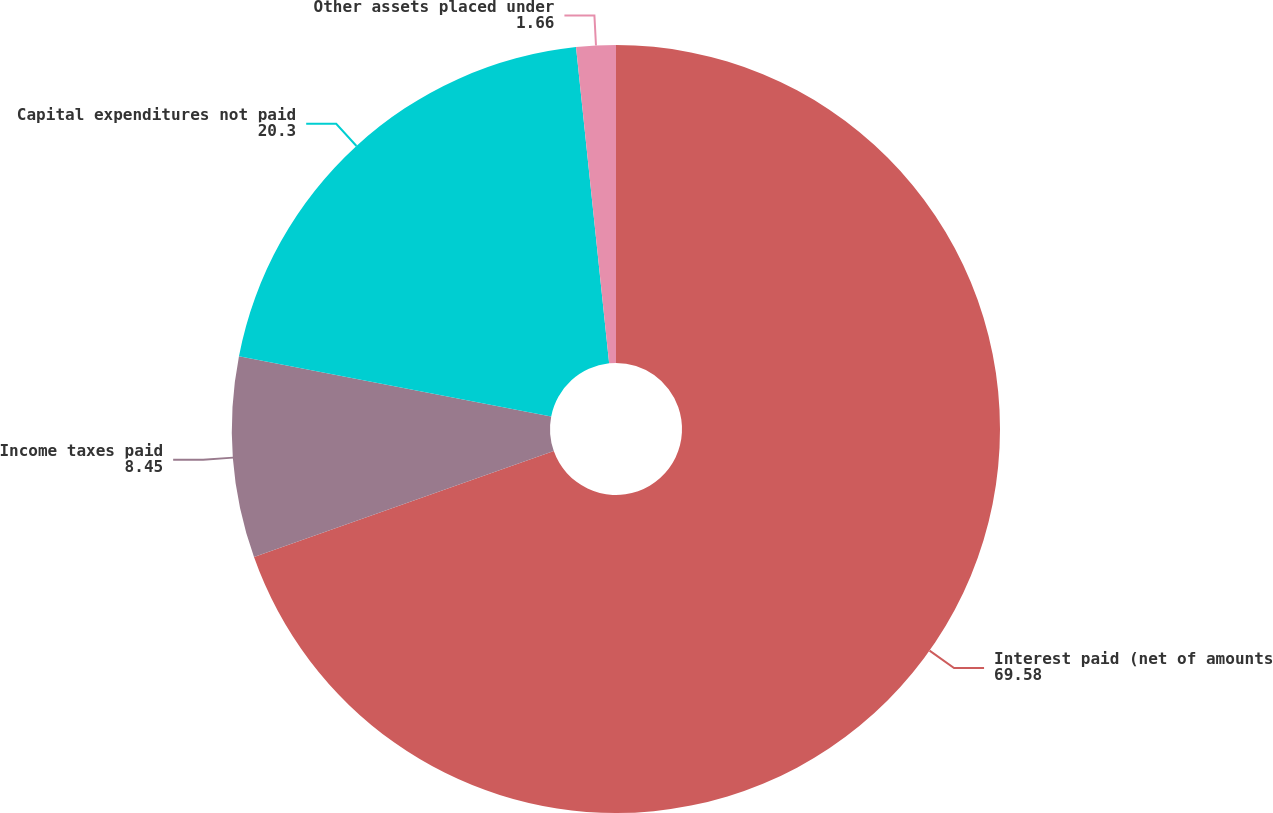<chart> <loc_0><loc_0><loc_500><loc_500><pie_chart><fcel>Interest paid (net of amounts<fcel>Income taxes paid<fcel>Capital expenditures not paid<fcel>Other assets placed under<nl><fcel>69.58%<fcel>8.45%<fcel>20.3%<fcel>1.66%<nl></chart> 